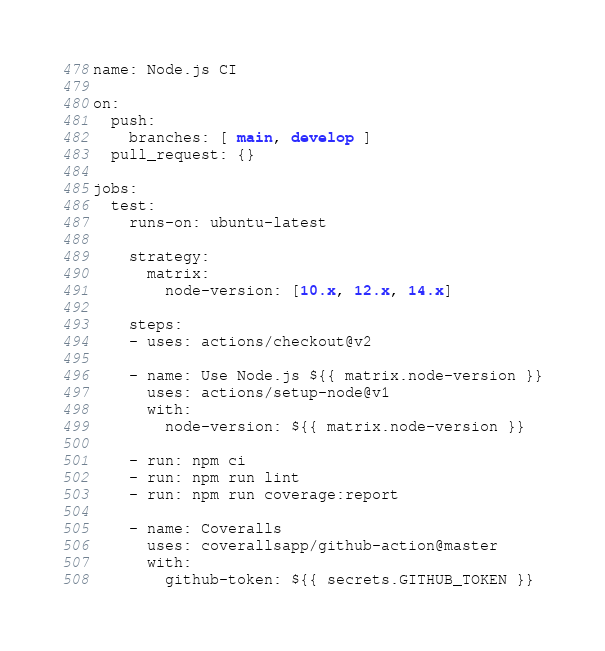<code> <loc_0><loc_0><loc_500><loc_500><_YAML_>
name: Node.js CI

on:
  push:
    branches: [ main, develop ]
  pull_request: {}

jobs:
  test:
    runs-on: ubuntu-latest

    strategy:
      matrix:
        node-version: [10.x, 12.x, 14.x]

    steps:
    - uses: actions/checkout@v2

    - name: Use Node.js ${{ matrix.node-version }}
      uses: actions/setup-node@v1
      with:
        node-version: ${{ matrix.node-version }}

    - run: npm ci
    - run: npm run lint
    - run: npm run coverage:report

    - name: Coveralls
      uses: coverallsapp/github-action@master
      with:
        github-token: ${{ secrets.GITHUB_TOKEN }}
</code> 